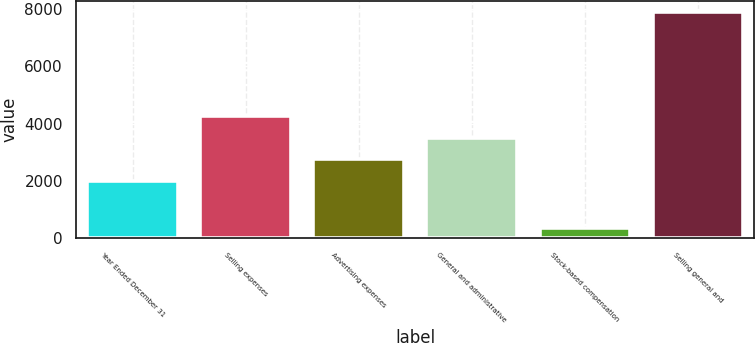Convert chart to OTSL. <chart><loc_0><loc_0><loc_500><loc_500><bar_chart><fcel>Year Ended December 31<fcel>Selling expenses<fcel>Advertising expenses<fcel>General and administrative<fcel>Stock-based compensation<fcel>Selling general and<nl><fcel>2004<fcel>4267.5<fcel>2758.5<fcel>3513<fcel>345<fcel>7890<nl></chart> 